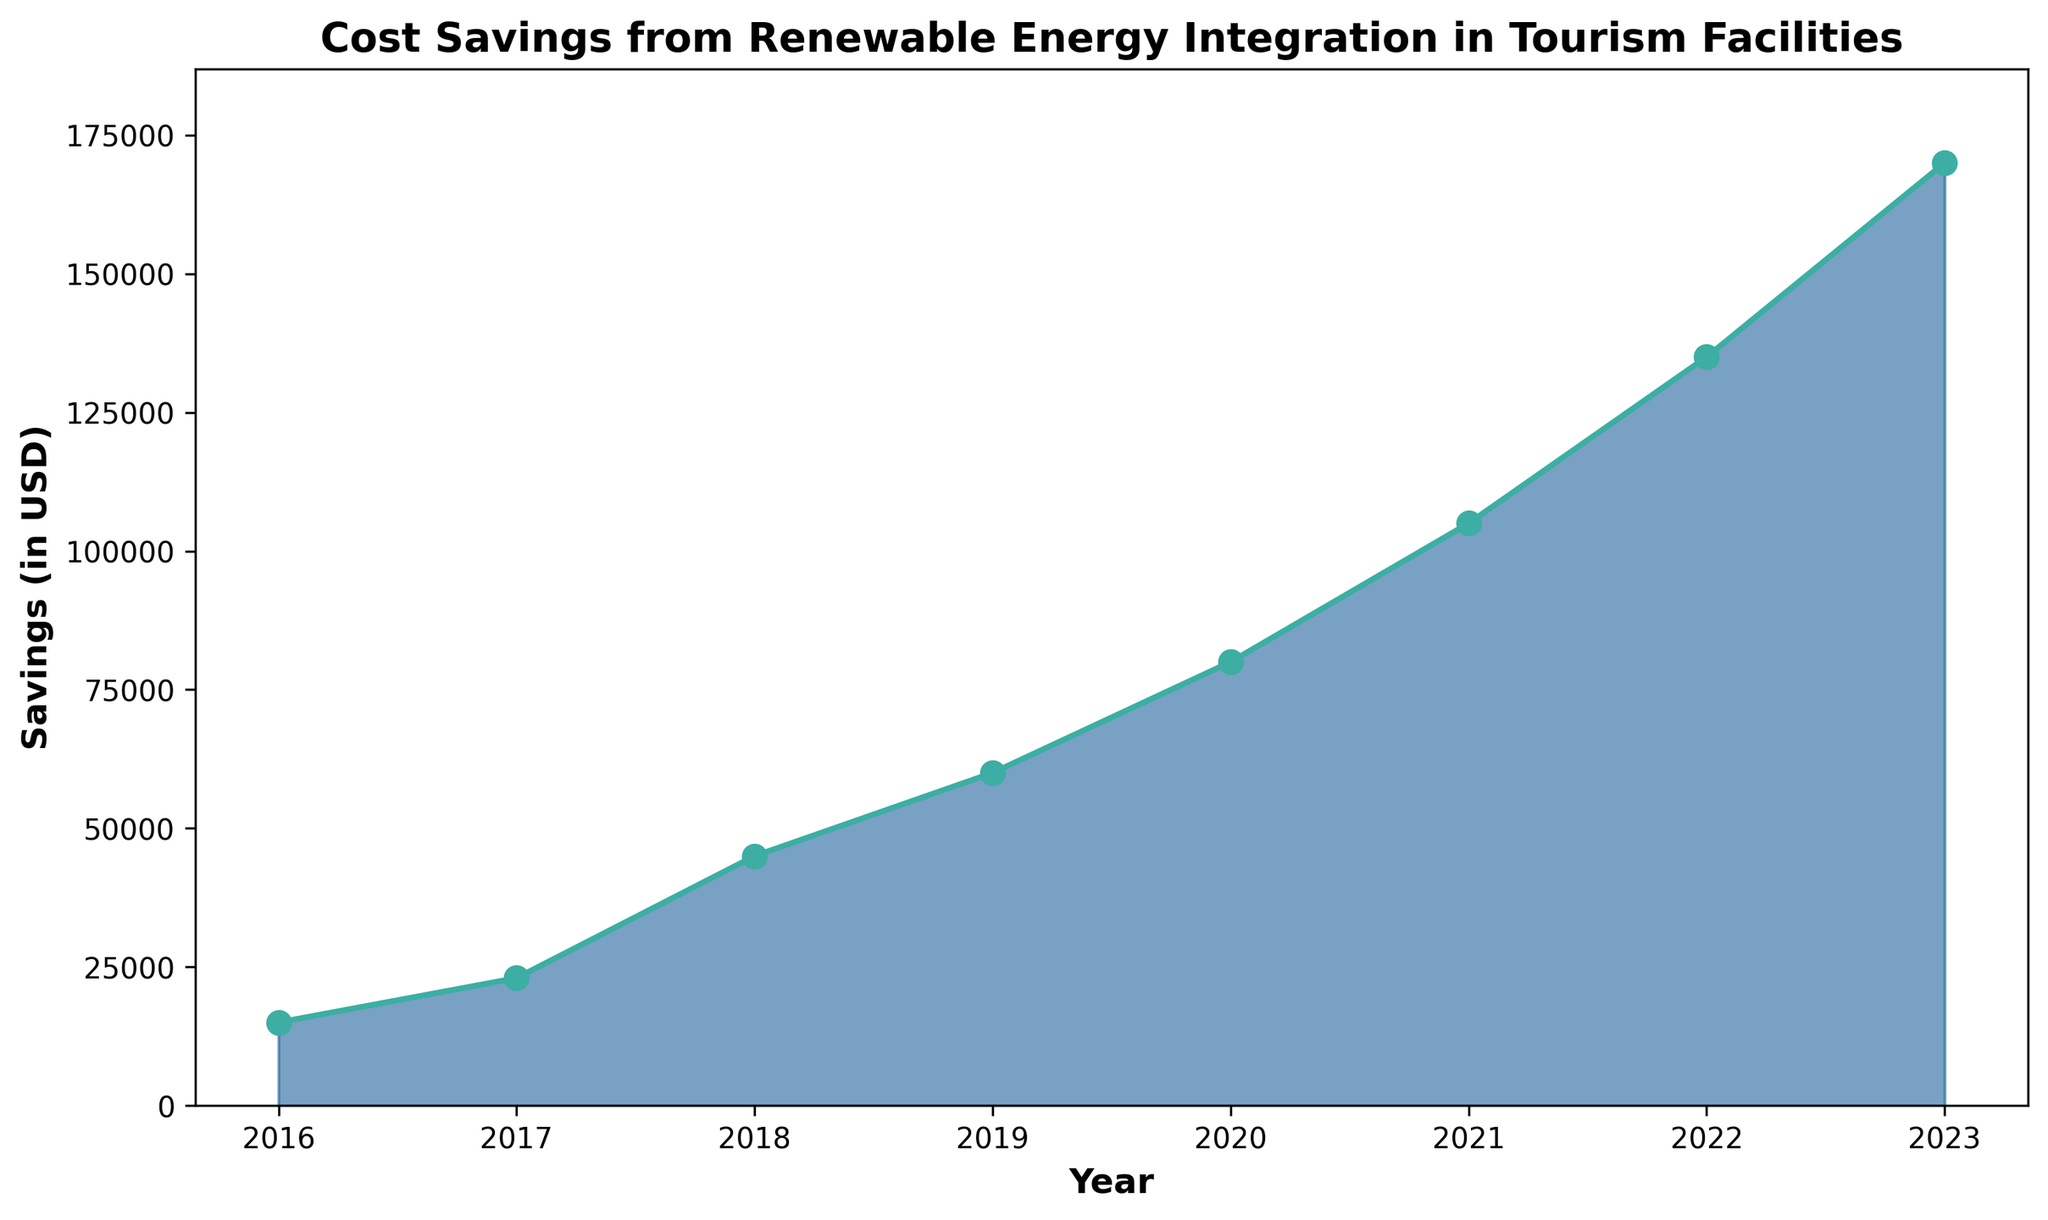What is the total cost savings accumulated from 2016 to 2023? To find the total accumulation, sum the yearly savings from 2016 to 2023: 15000 + 23000 + 45000 + 60000 + 80000 + 105000 + 135000 + 170000 = 633000.
Answer: 633000 Which year shows the highest cost savings? Refer to the peak value on the y-axis compared to each year along the x-axis; 2023 shows the highest savings at 170000 USD.
Answer: 2023 By how much did cost savings increase from 2018 to 2020? Subtract the 2018 savings (45000) from the 2020 savings (80000): 80000 - 45000 = 35000.
Answer: 35000 What is the average annual cost savings from 2016 to 2023? Sum the yearly savings (total 633000) and divide by the number of years (8): 633000/8 = 79125.
Answer: 79125 Which year had the smallest increase in savings compared to the previous year? Calculate the difference year-over-year: 2017-2016 (8000), 2018-2017 (22000), 2019-2018 (15000), 2020-2019 (20000), 2021-2020 (25000), 2022-2021 (30000), 2023-2022 (35000). The smallest increase is from 2016 to 2017 (8000).
Answer: 2017 How did the trend of cost savings change from 2019 to 2020? Visually compare the slope between the points for these years; a steeper increase is observed, indicating a higher rate of savings growth from 2019 to 2020.
Answer: Steeper increase What's the difference in cost savings between 2016 and 2021? Subtract the 2016 savings (15000) from the 2021 savings (105000): 105000 - 15000 = 90000.
Answer: 90000 Is the growth in cost savings consistent every year? By visual inspection, observe the differences in the slope between consecutive years; while overall positive, the growth rate varies each year.
Answer: No What is the median value of the cost savings from 2016 to 2023? Arrange the savings values in ascending order (15000, 23000, 45000, 60000, 80000, 105000, 135000, 170000) and find the middle value; the median for an even number of observations is the average of the 4th and 5th values: (60000 + 80000)/2 = 70000.
Answer: 70000 Compare the cost savings in 2022 with 2017. How many times greater are the savings in 2022? Divide the savings in 2022 (135000) by the savings in 2017 (23000): 135000 / 23000 ≈ 5.87 times greater.
Answer: 5.87 times 